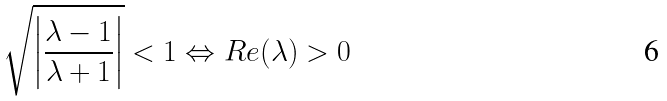Convert formula to latex. <formula><loc_0><loc_0><loc_500><loc_500>\sqrt { \left | \frac { \lambda - 1 } { \lambda + 1 } \right | } < 1 \Leftrightarrow R e ( \lambda ) > 0</formula> 